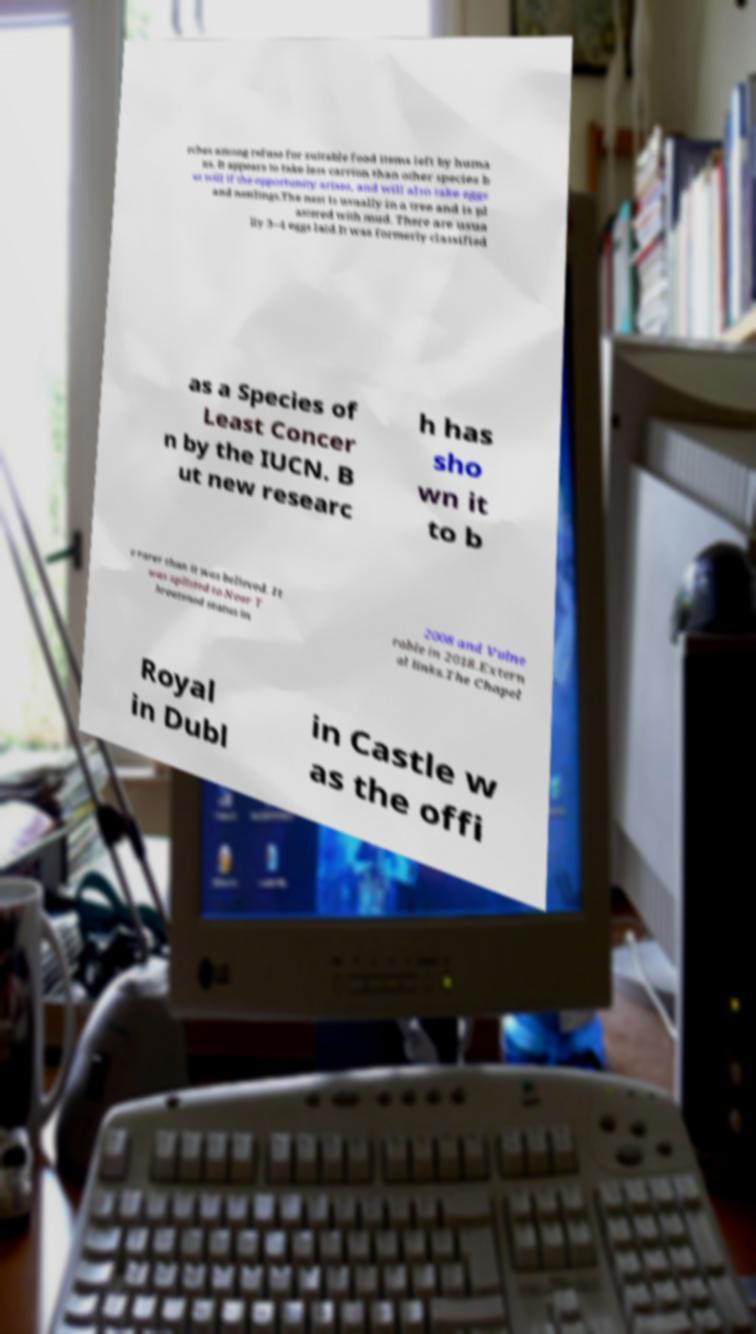There's text embedded in this image that I need extracted. Can you transcribe it verbatim? rches among refuse for suitable food items left by huma ns. It appears to take less carrion than other species b ut will if the opportunity arises, and will also take eggs and nestlings.The nest is usually in a tree and is pl astered with mud. There are usua lly 3–4 eggs laid.It was formerly classified as a Species of Least Concer n by the IUCN. B ut new researc h has sho wn it to b e rarer than it was believed. It was uplisted to Near T hreatened status in 2008 and Vulne rable in 2018.Extern al links.The Chapel Royal in Dubl in Castle w as the offi 